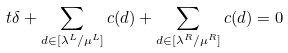<formula> <loc_0><loc_0><loc_500><loc_500>t \delta + \sum _ { d \in [ \lambda ^ { L } / \mu ^ { L } ] } c ( d ) + \sum _ { d \in [ \lambda ^ { R } / \mu ^ { R } ] } c ( d ) = 0</formula> 